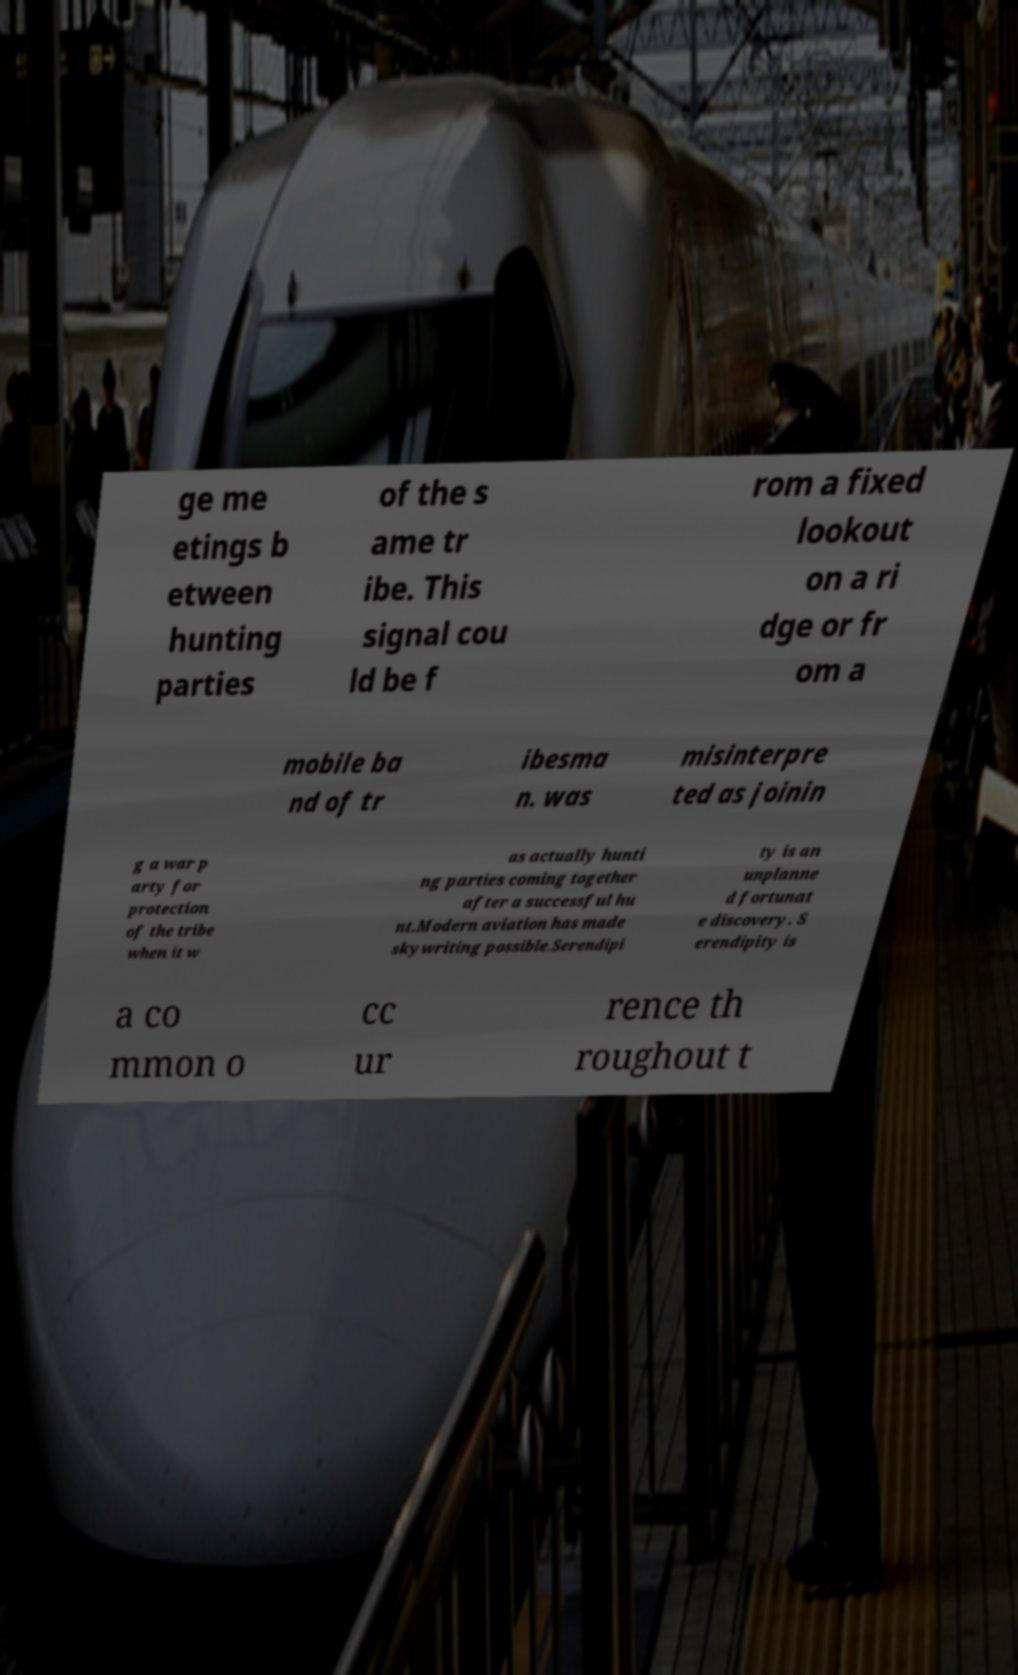Could you extract and type out the text from this image? ge me etings b etween hunting parties of the s ame tr ibe. This signal cou ld be f rom a fixed lookout on a ri dge or fr om a mobile ba nd of tr ibesma n. was misinterpre ted as joinin g a war p arty for protection of the tribe when it w as actually hunti ng parties coming together after a successful hu nt.Modern aviation has made skywriting possible.Serendipi ty is an unplanne d fortunat e discovery. S erendipity is a co mmon o cc ur rence th roughout t 